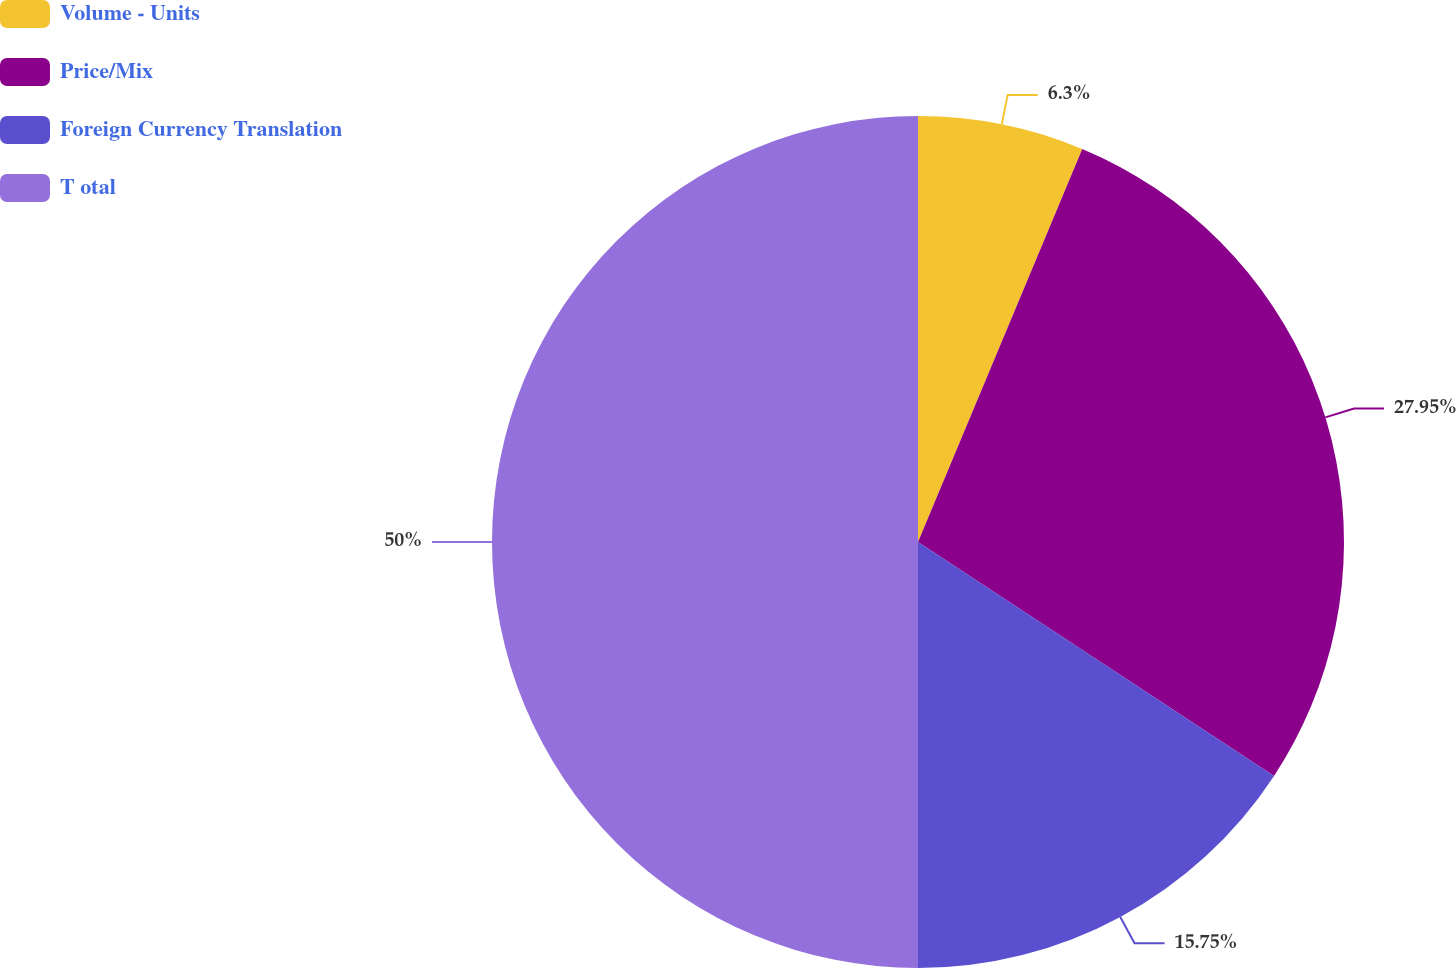<chart> <loc_0><loc_0><loc_500><loc_500><pie_chart><fcel>Volume - Units<fcel>Price/Mix<fcel>Foreign Currency Translation<fcel>T otal<nl><fcel>6.3%<fcel>27.95%<fcel>15.75%<fcel>50.0%<nl></chart> 